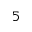<formula> <loc_0><loc_0><loc_500><loc_500>_ { 5 }</formula> 